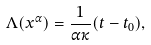Convert formula to latex. <formula><loc_0><loc_0><loc_500><loc_500>\Lambda ( x ^ { \alpha } ) = \frac { 1 } { \alpha \kappa } ( t - t _ { 0 } ) ,</formula> 